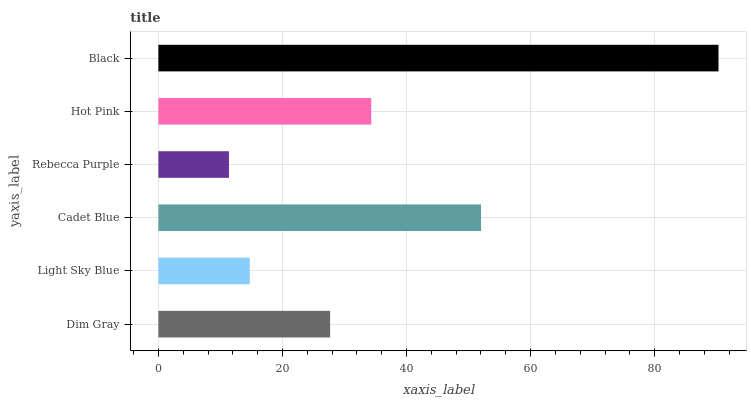Is Rebecca Purple the minimum?
Answer yes or no. Yes. Is Black the maximum?
Answer yes or no. Yes. Is Light Sky Blue the minimum?
Answer yes or no. No. Is Light Sky Blue the maximum?
Answer yes or no. No. Is Dim Gray greater than Light Sky Blue?
Answer yes or no. Yes. Is Light Sky Blue less than Dim Gray?
Answer yes or no. Yes. Is Light Sky Blue greater than Dim Gray?
Answer yes or no. No. Is Dim Gray less than Light Sky Blue?
Answer yes or no. No. Is Hot Pink the high median?
Answer yes or no. Yes. Is Dim Gray the low median?
Answer yes or no. Yes. Is Dim Gray the high median?
Answer yes or no. No. Is Black the low median?
Answer yes or no. No. 